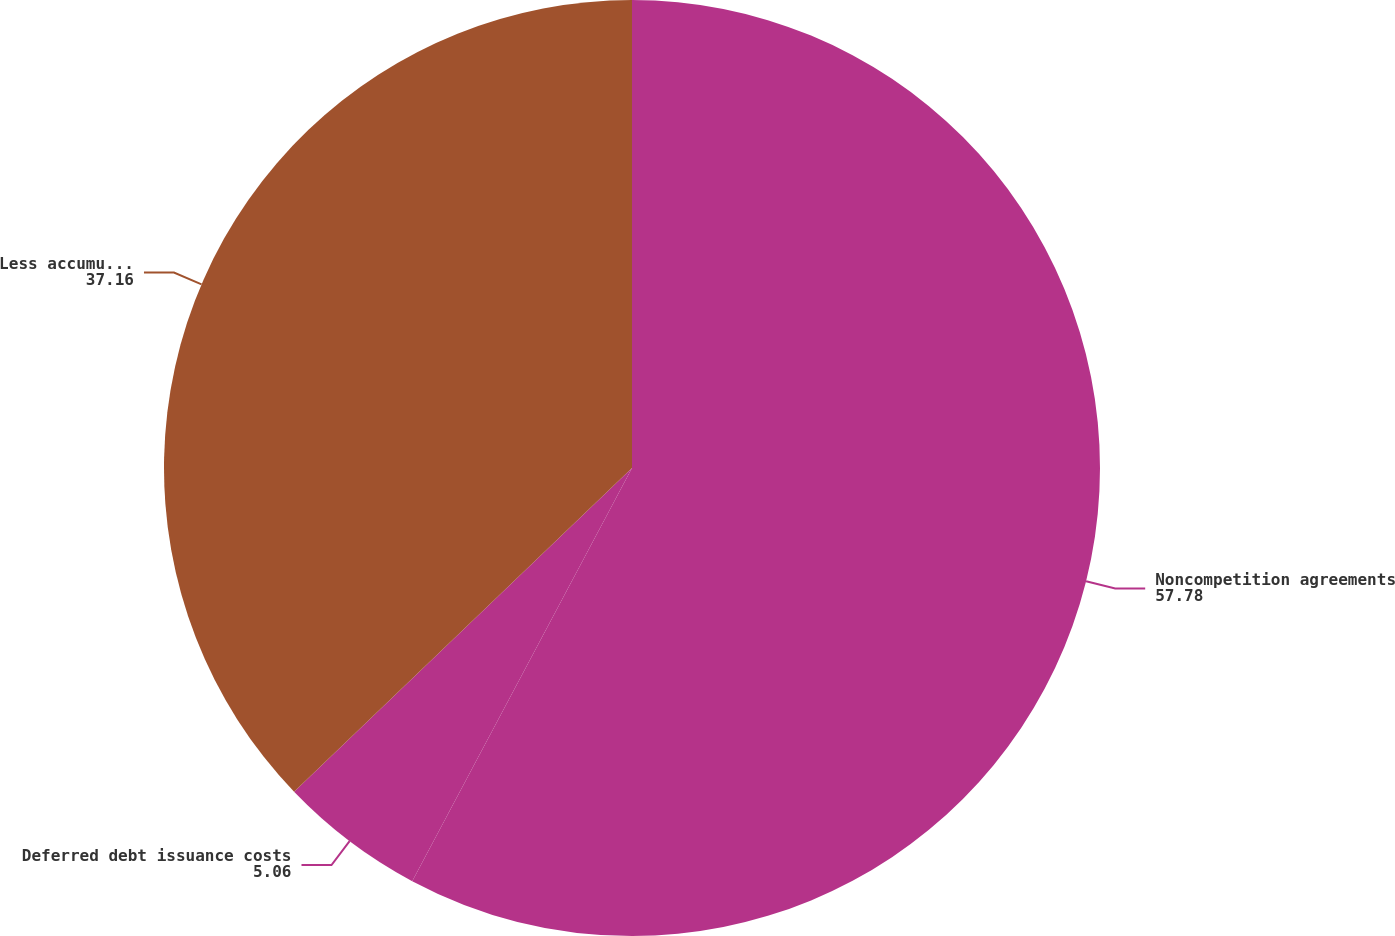Convert chart to OTSL. <chart><loc_0><loc_0><loc_500><loc_500><pie_chart><fcel>Noncompetition agreements<fcel>Deferred debt issuance costs<fcel>Less accumulated amortization<nl><fcel>57.78%<fcel>5.06%<fcel>37.16%<nl></chart> 